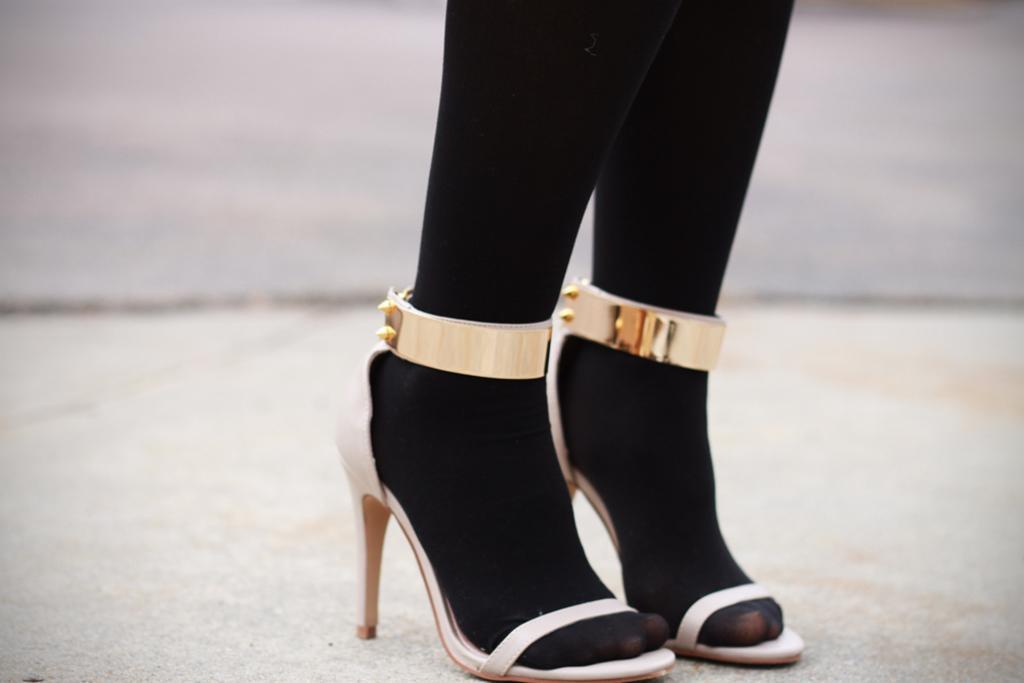How would you summarize this image in a sentence or two? In this image we can see the legs of a woman wearing sandals. 